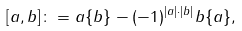<formula> <loc_0><loc_0><loc_500><loc_500>[ a , b ] \colon = a \{ b \} - ( - 1 ) ^ { | a | \cdot | b | } b \{ a \} ,</formula> 